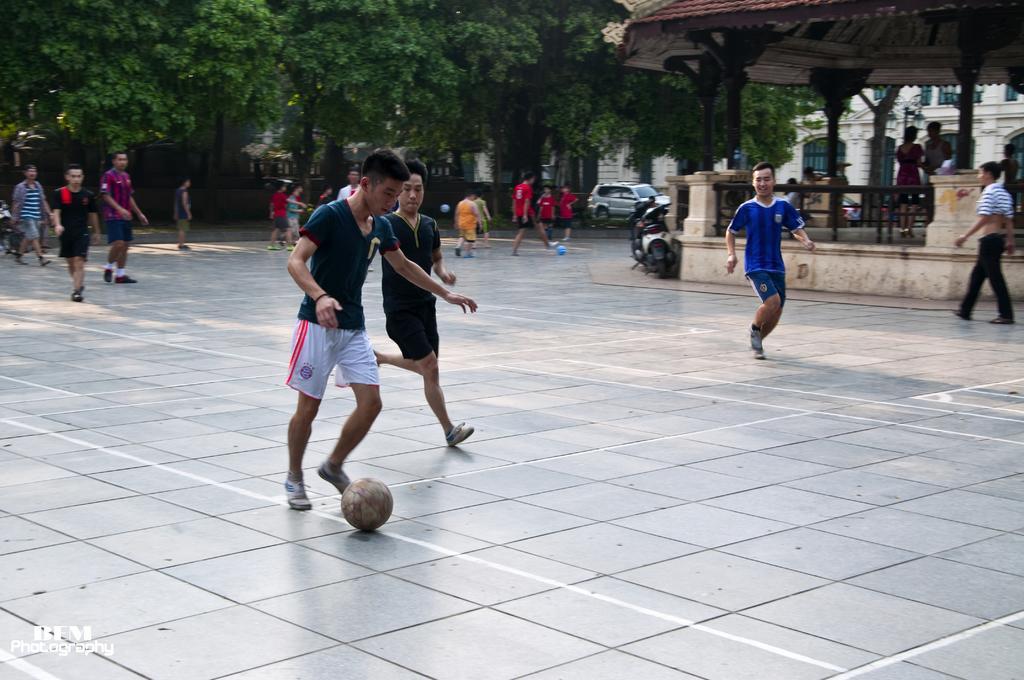Could you give a brief overview of what you see in this image? In this image, we can see few people are playing football with balls on the floor. Background we can see a building with wall. Here we can see pillars, shed, railing, vehicles, trees. Here we can see few people are walking. Left side bottom, we can see the watermark in the image. 